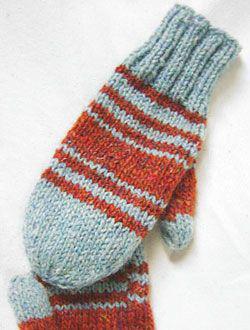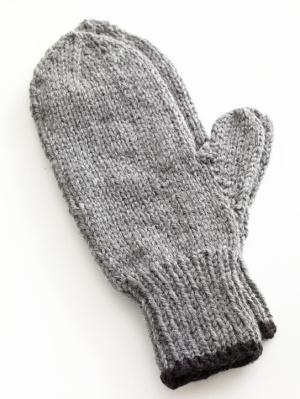The first image is the image on the left, the second image is the image on the right. Given the left and right images, does the statement "One pair of mittons has a visible animal design knitted in, and the other pair does not." hold true? Answer yes or no. No. The first image is the image on the left, the second image is the image on the right. For the images shown, is this caption "A pair of gloves is worn by a human." true? Answer yes or no. No. 